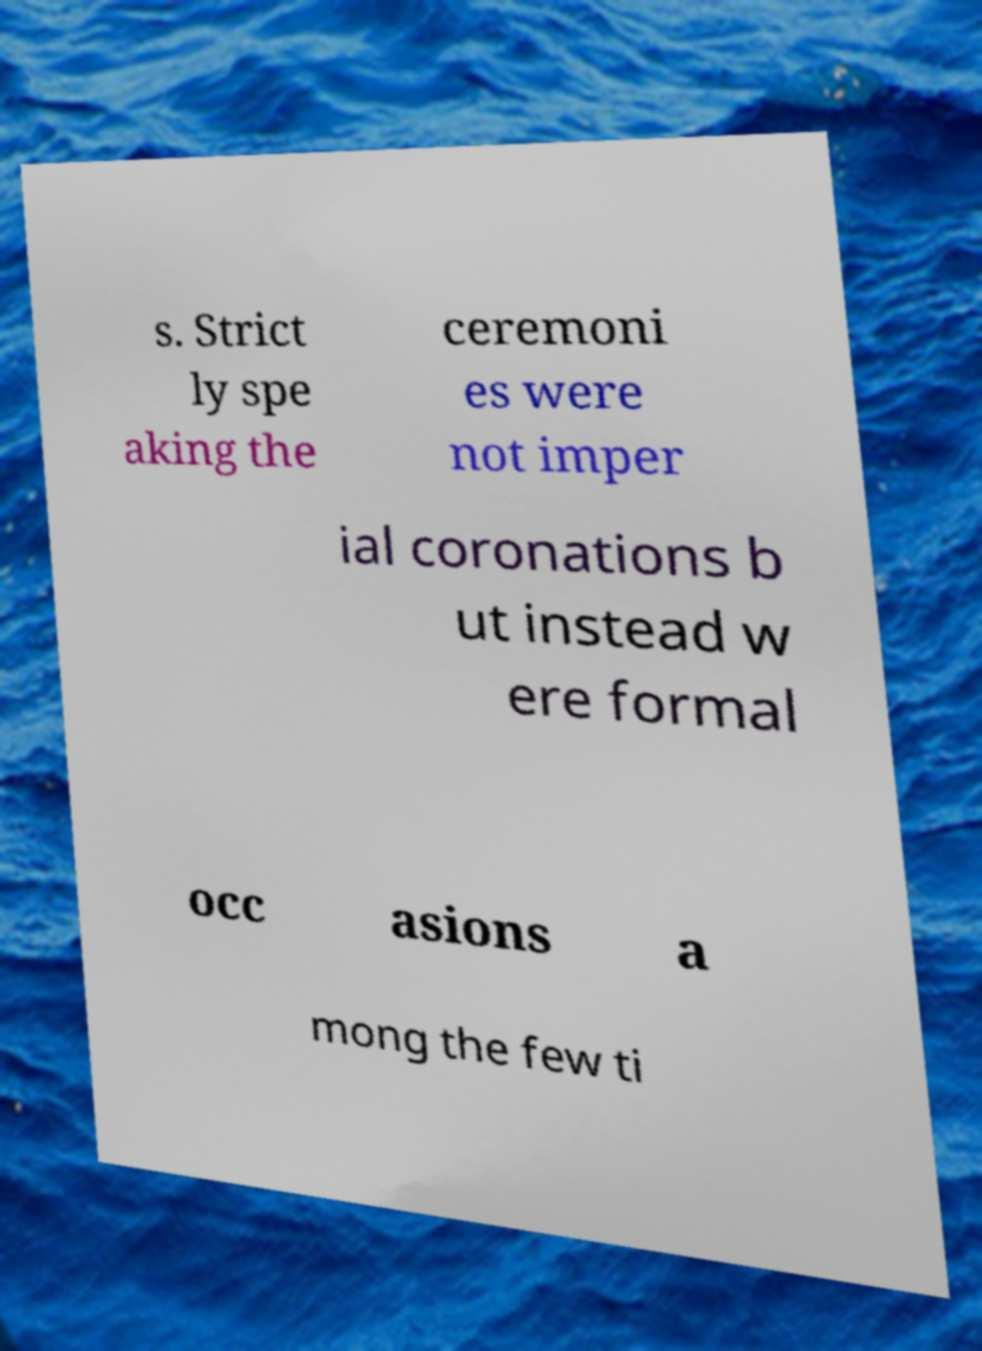Please read and relay the text visible in this image. What does it say? s. Strict ly spe aking the ceremoni es were not imper ial coronations b ut instead w ere formal occ asions a mong the few ti 